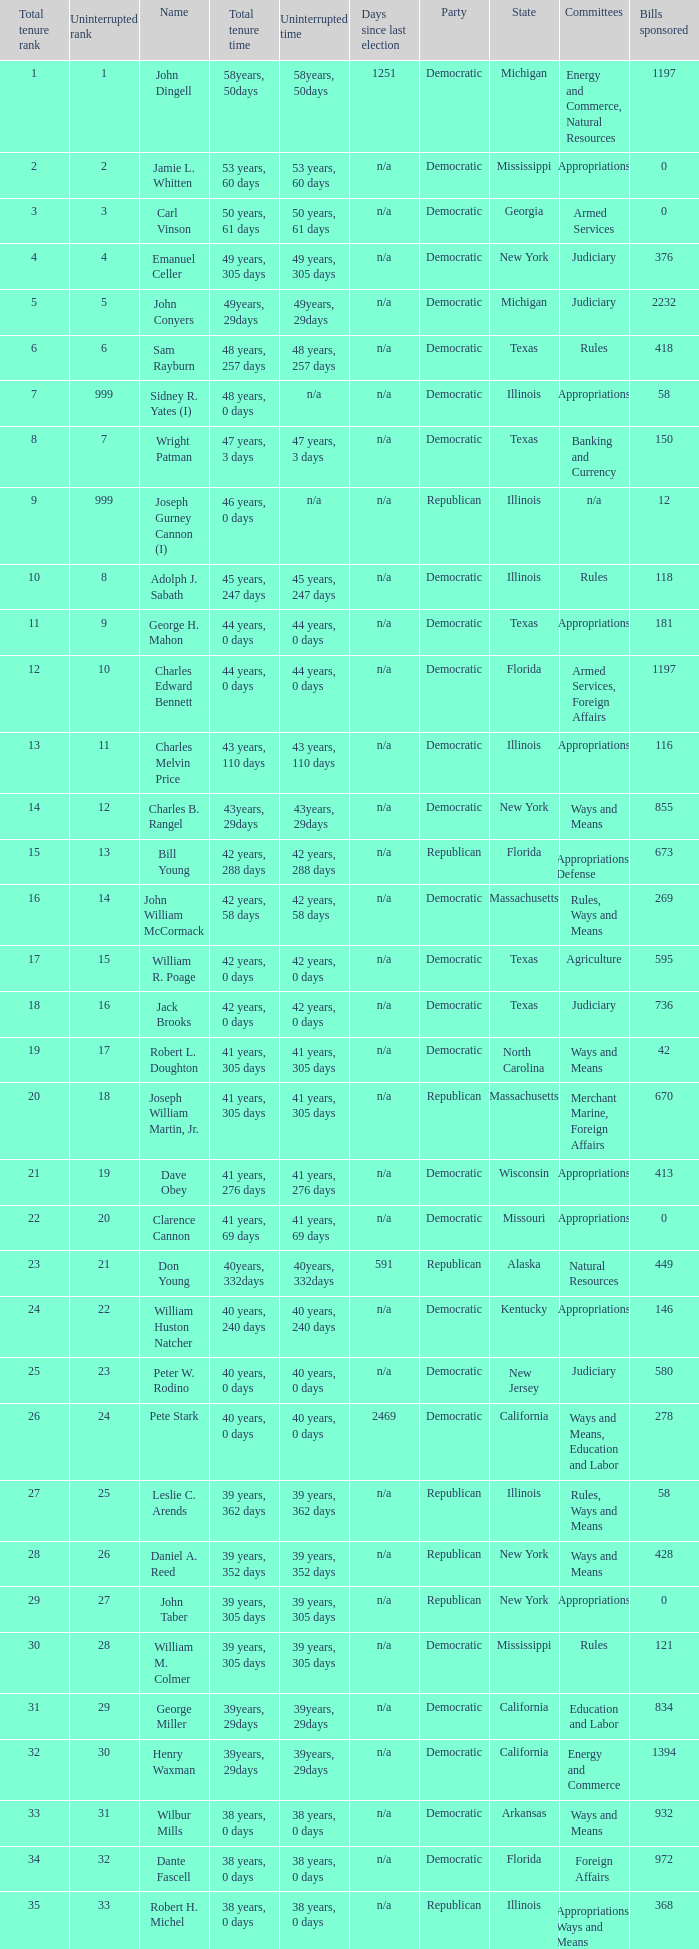How many uninterrupted ranks does john dingell have? 1.0. 